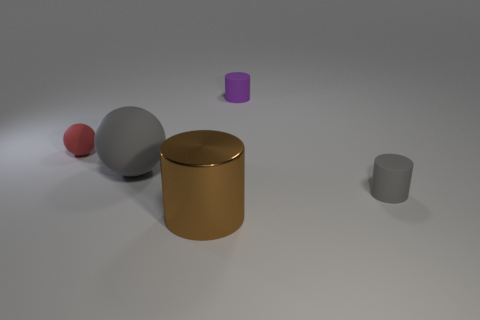What color is the tiny cylinder to the left of the thing that is to the right of the object behind the tiny red matte sphere?
Ensure brevity in your answer.  Purple. Is the number of big gray rubber things the same as the number of large yellow balls?
Offer a very short reply. No. How many purple objects are either large metallic cylinders or tiny rubber blocks?
Make the answer very short. 0. How many other tiny red matte objects are the same shape as the red thing?
Your answer should be compact. 0. The purple rubber thing that is the same size as the gray matte cylinder is what shape?
Provide a succinct answer. Cylinder. There is a tiny purple thing; are there any rubber cylinders right of it?
Your response must be concise. Yes. There is a gray matte object on the left side of the large brown cylinder; are there any big things that are behind it?
Your answer should be compact. No. Are there fewer big things that are behind the brown shiny cylinder than big shiny objects behind the red matte ball?
Your response must be concise. No. Are there any other things that have the same size as the brown cylinder?
Offer a very short reply. Yes. What shape is the tiny red matte object?
Give a very brief answer. Sphere. 